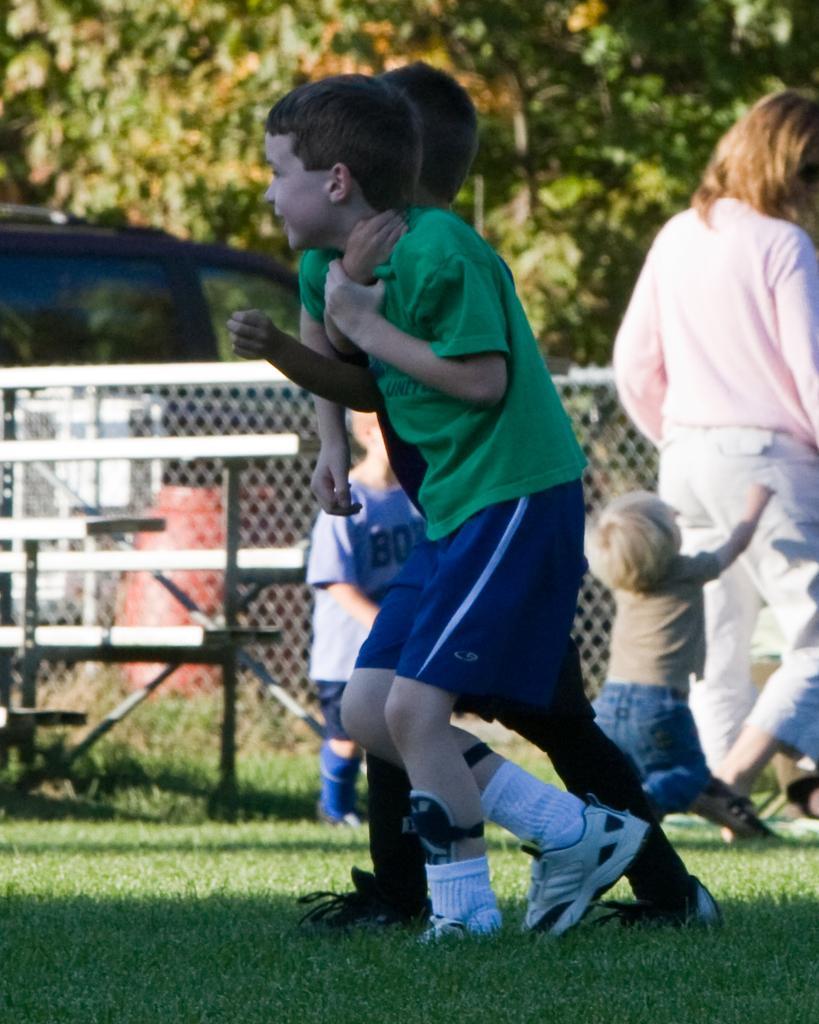Please provide a concise description of this image. In this image in front there are two people running on the grass. Behind them there are a few other people. In the center of the image there is a metal fence. In the background of the image there is a car. There are trees. 